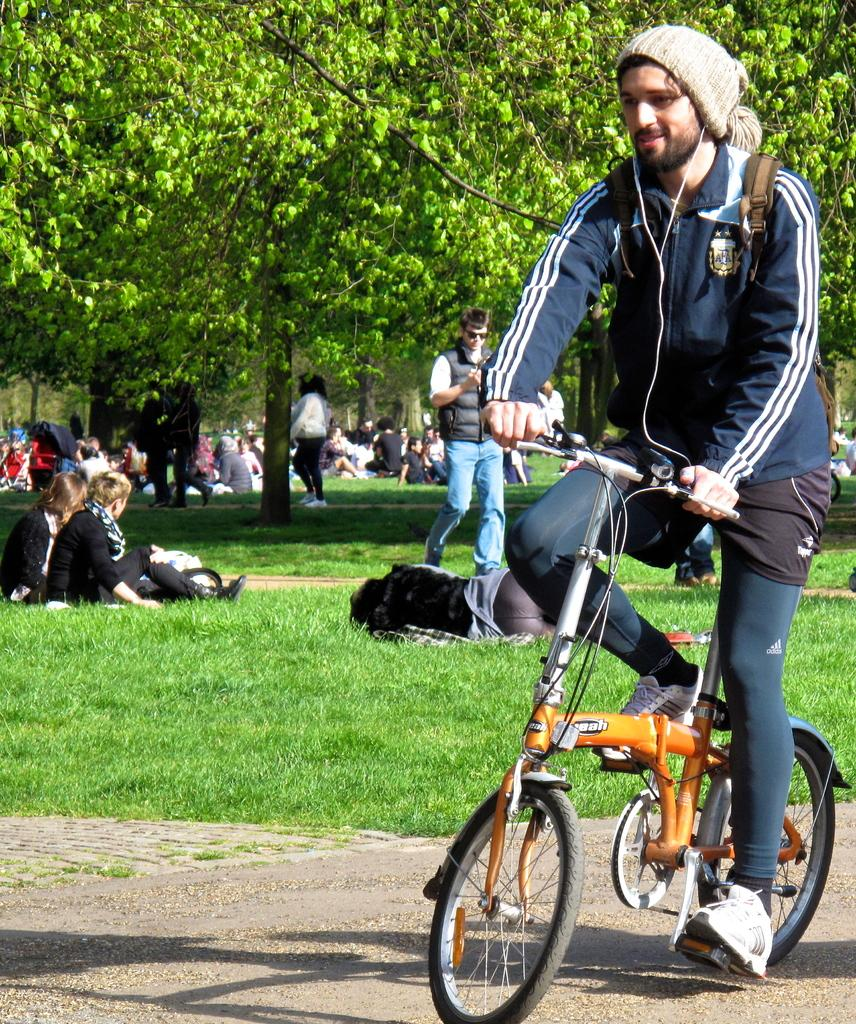What are the people in the image doing under the trees? The people in the image are sitting and sleeping under trees on the grass. What else can be observed about the people in the image? There are also people walking in the area. Is there any transportation visible in the image? Yes, there is a man riding a bicycle on the road. What type of feather can be seen on the goat in the image? There is no goat or feather present in the image. How many goats are part of the flock in the image? There is no flock or goat present in the image. 